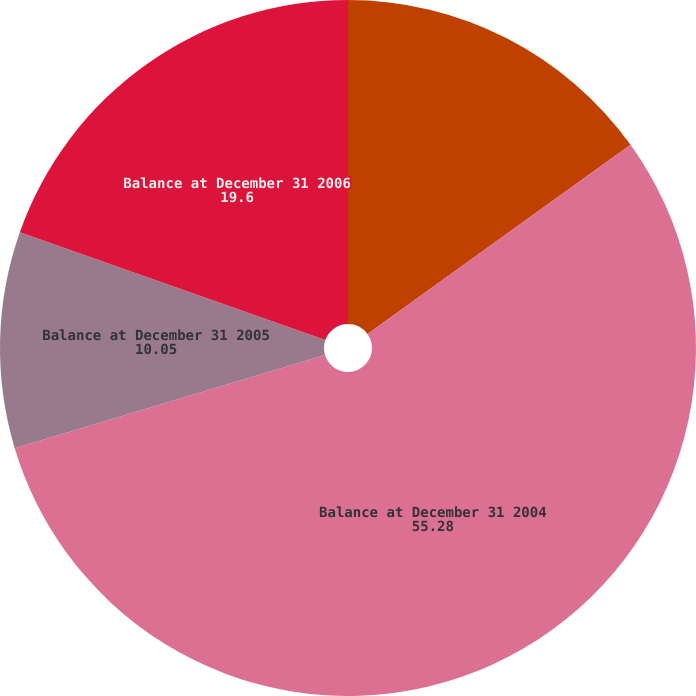Convert chart. <chart><loc_0><loc_0><loc_500><loc_500><pie_chart><fcel>Balance at December 31 2003<fcel>Balance at December 31 2004<fcel>Balance at December 31 2005<fcel>Balance at December 31 2006<nl><fcel>15.08%<fcel>55.28%<fcel>10.05%<fcel>19.6%<nl></chart> 